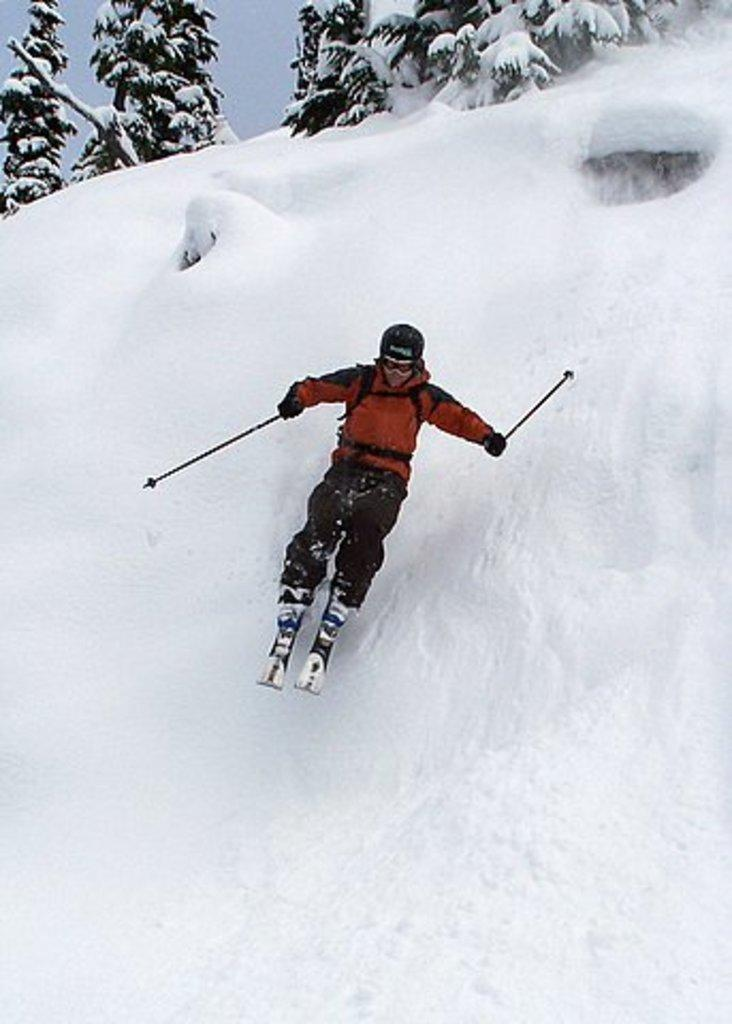What is the person in the image doing? The person is using skis in the image. Where is the person located? The person is in the snow. What can be seen in the background of the image? There are trees in the image. What type of plough is being used to turn the pages in the image? There is no plough or pages present in the image; it features a person using skis in the snow with trees in the background. 